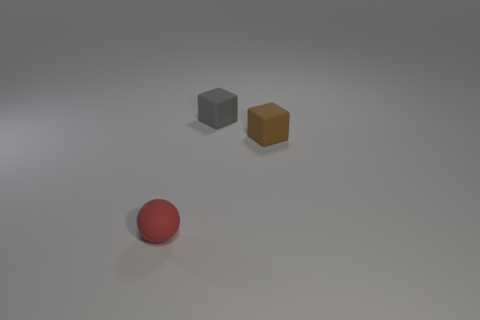What materials do the objects in the image look like they are made from? The objects in the image have a matte finish and could be made of a plastic or a lightweight composite material, based on the reflections and texture. 